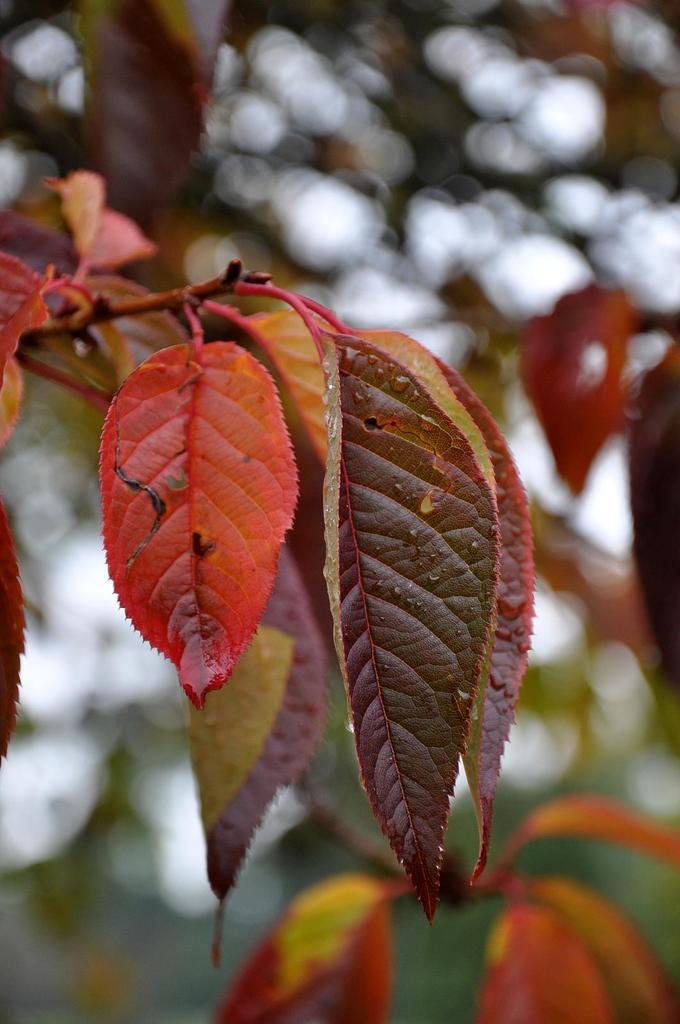What type of vegetation is visible in the image? There are leaves of a tree in the image. Can you describe the leaves in more detail? The leaves appear to be green and are likely from a deciduous tree. What might be the purpose of these leaves in the context of the tree? The leaves are responsible for photosynthesis, which allows the tree to produce energy from sunlight. What type of baseball equipment can be seen in the image? There is no baseball equipment present in the image; it only features leaves of a tree. 